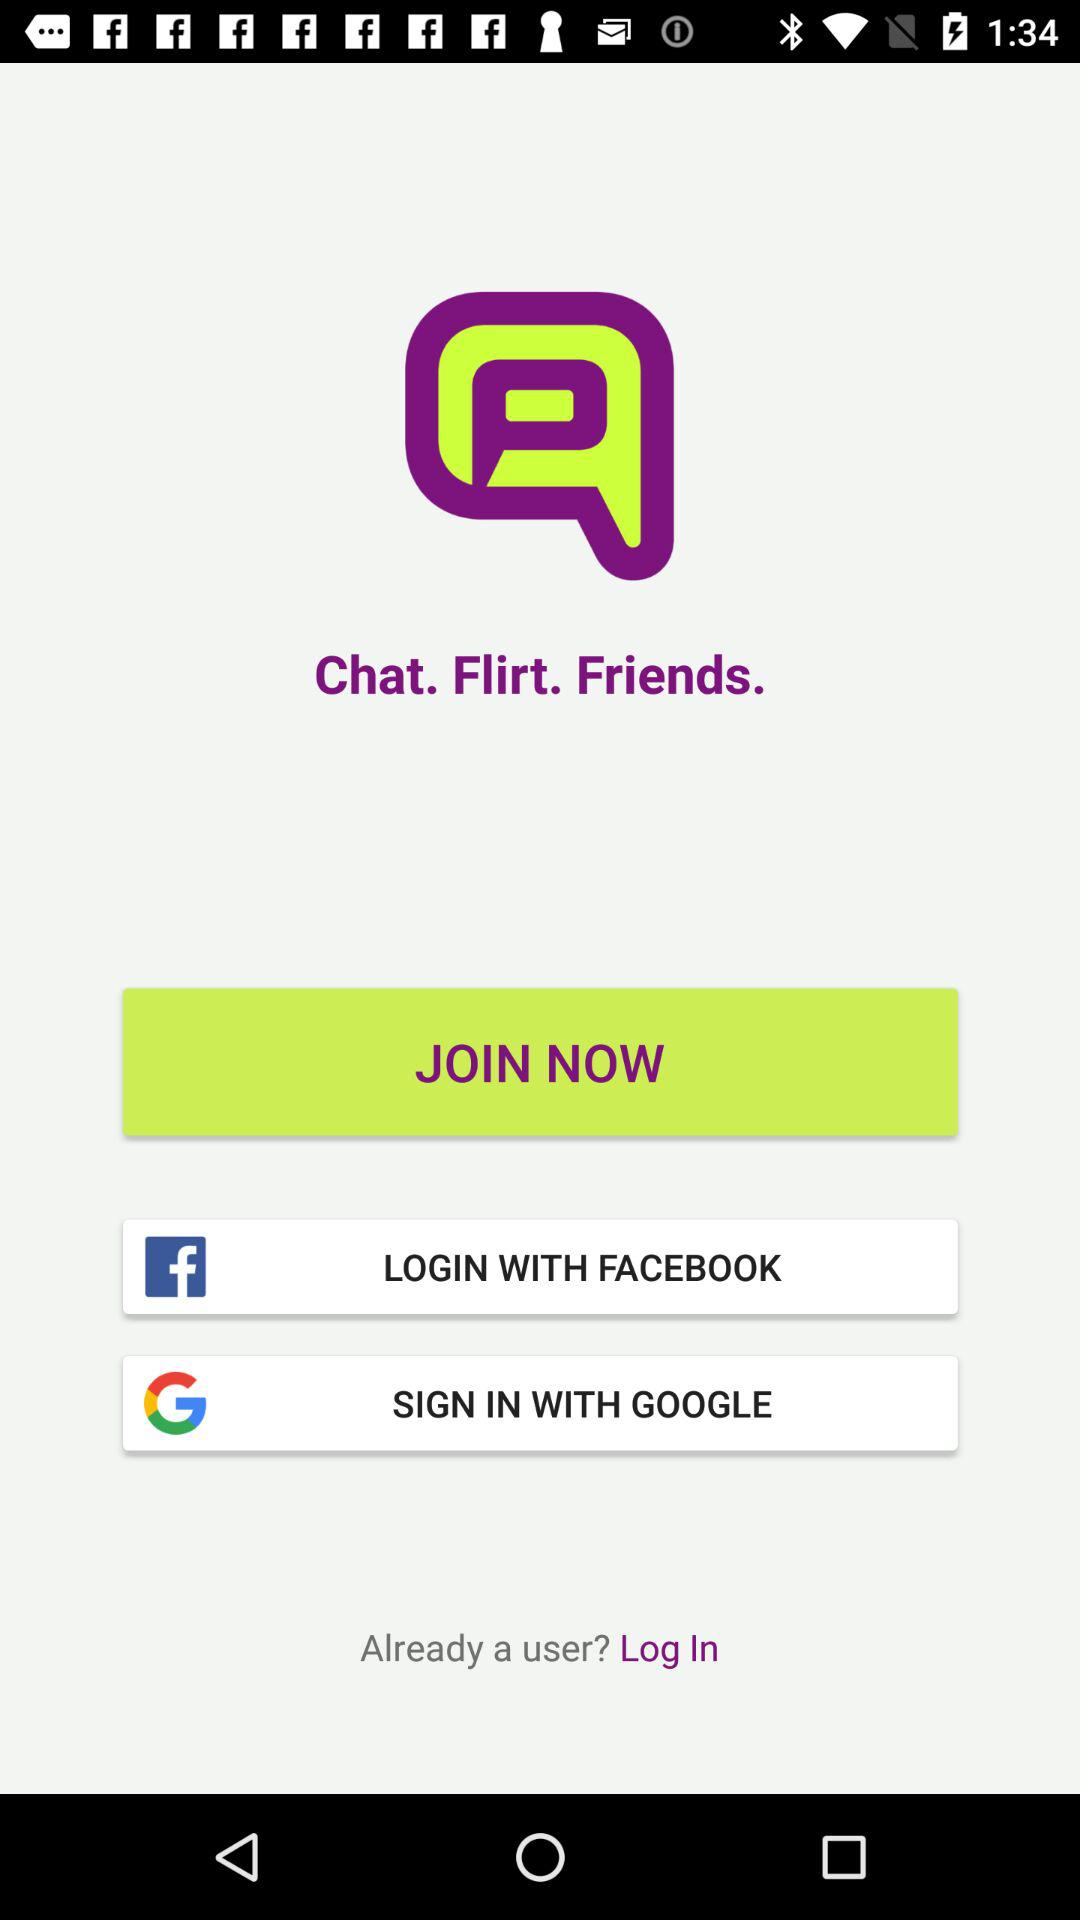What application is used for sign in? The applications used for sign in are "FACEBOOK" and "GOOGLE". 